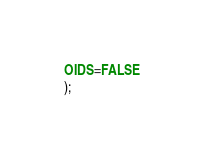<code> <loc_0><loc_0><loc_500><loc_500><_SQL_>OIDS=FALSE
);

</code> 